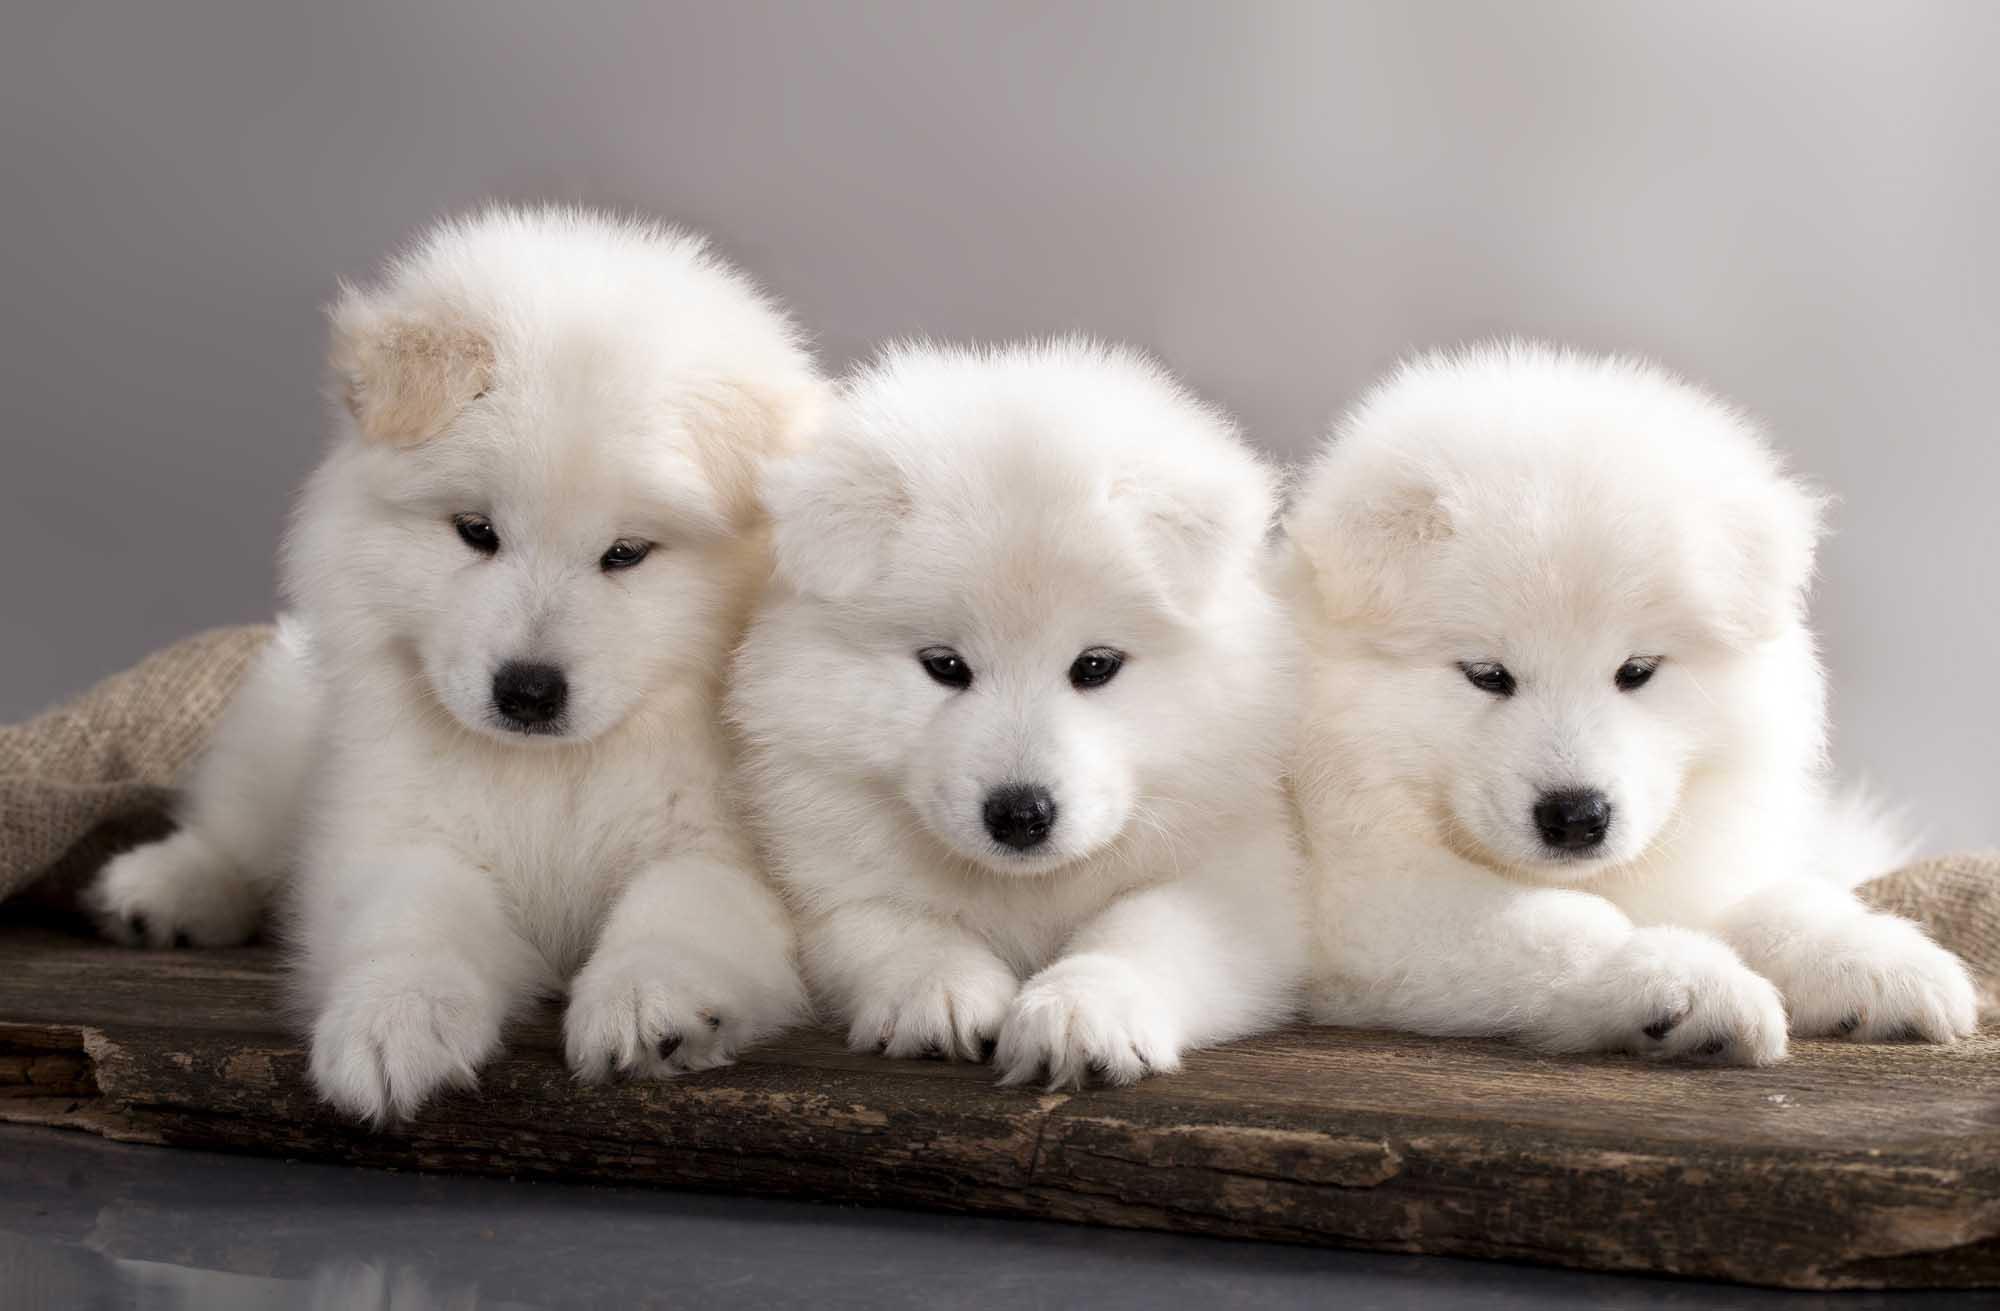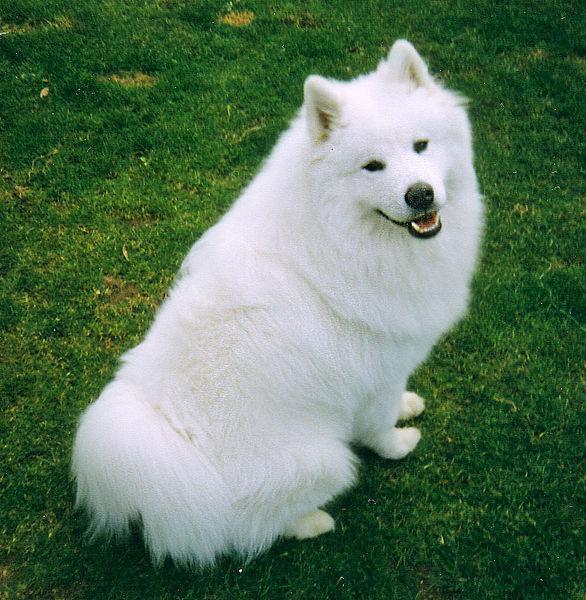The first image is the image on the left, the second image is the image on the right. Examine the images to the left and right. Is the description "There are 4 total puppies" accurate? Answer yes or no. No. The first image is the image on the left, the second image is the image on the right. Given the left and right images, does the statement "The left image contains at least two white dogs." hold true? Answer yes or no. Yes. The first image is the image on the left, the second image is the image on the right. Examine the images to the left and right. Is the description "Each image contains exactly one white dog, and one of the dogs is standing on all fours." accurate? Answer yes or no. No. The first image is the image on the left, the second image is the image on the right. Evaluate the accuracy of this statement regarding the images: "There are four dogs.". Is it true? Answer yes or no. Yes. 